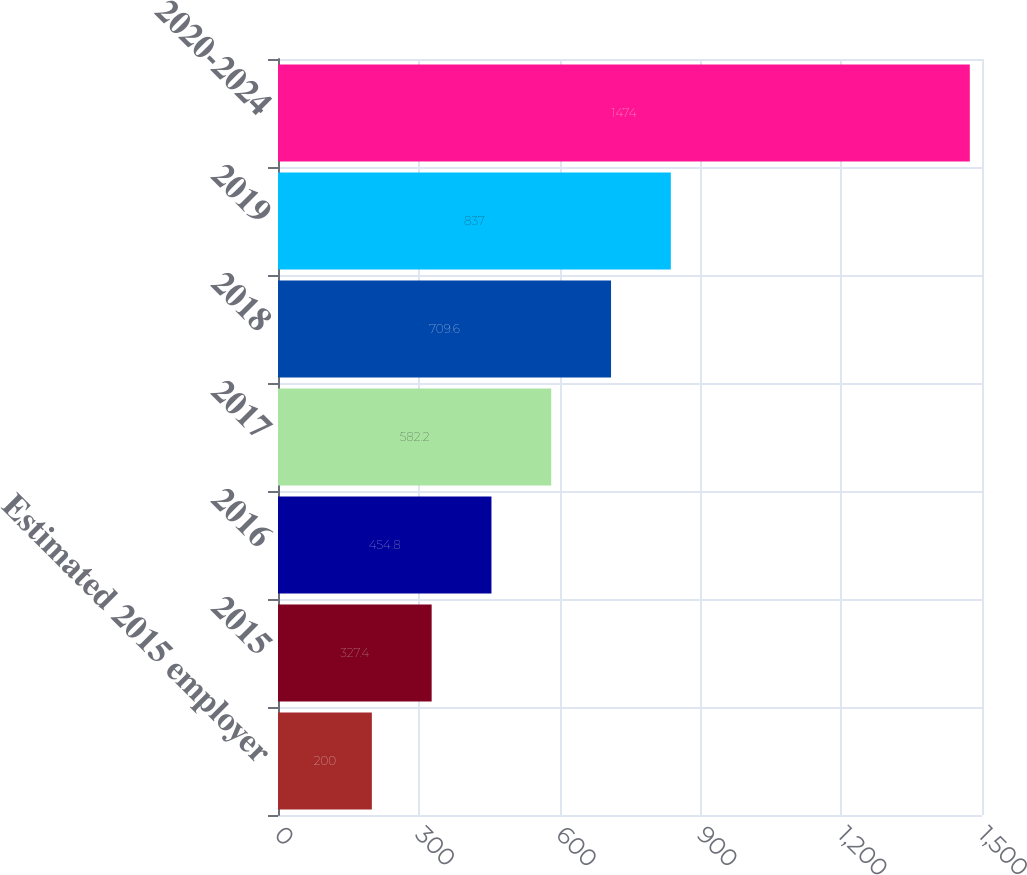<chart> <loc_0><loc_0><loc_500><loc_500><bar_chart><fcel>Estimated 2015 employer<fcel>2015<fcel>2016<fcel>2017<fcel>2018<fcel>2019<fcel>2020-2024<nl><fcel>200<fcel>327.4<fcel>454.8<fcel>582.2<fcel>709.6<fcel>837<fcel>1474<nl></chart> 